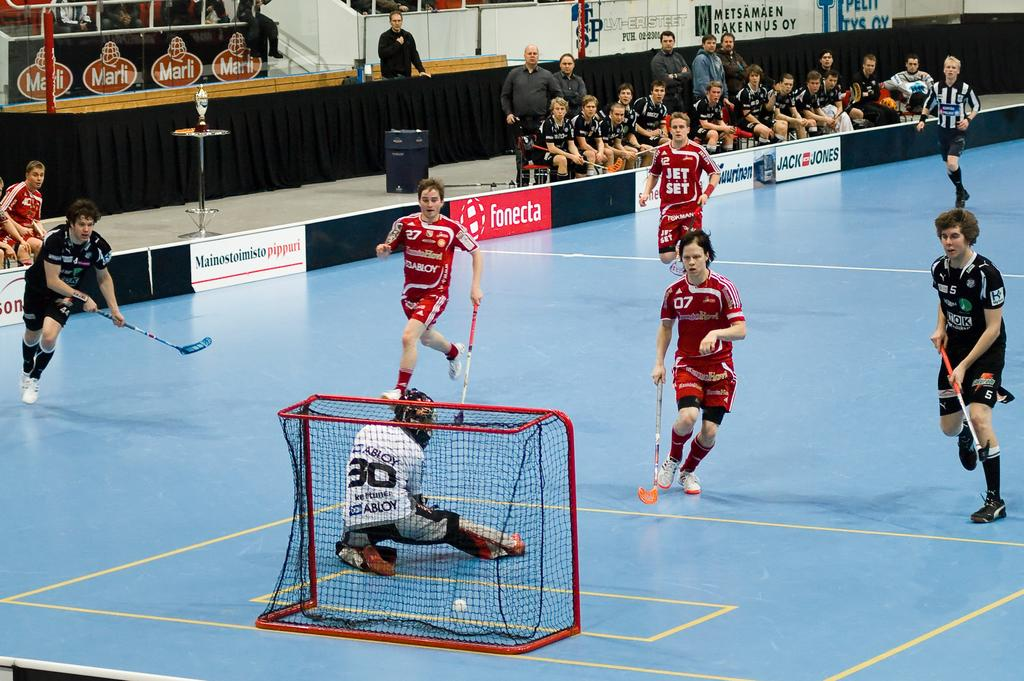<image>
Provide a brief description of the given image. the number 30 goalkeeper stops a shot on the ice hockey rink in front of advertising for Foneta and Jack Jones. 